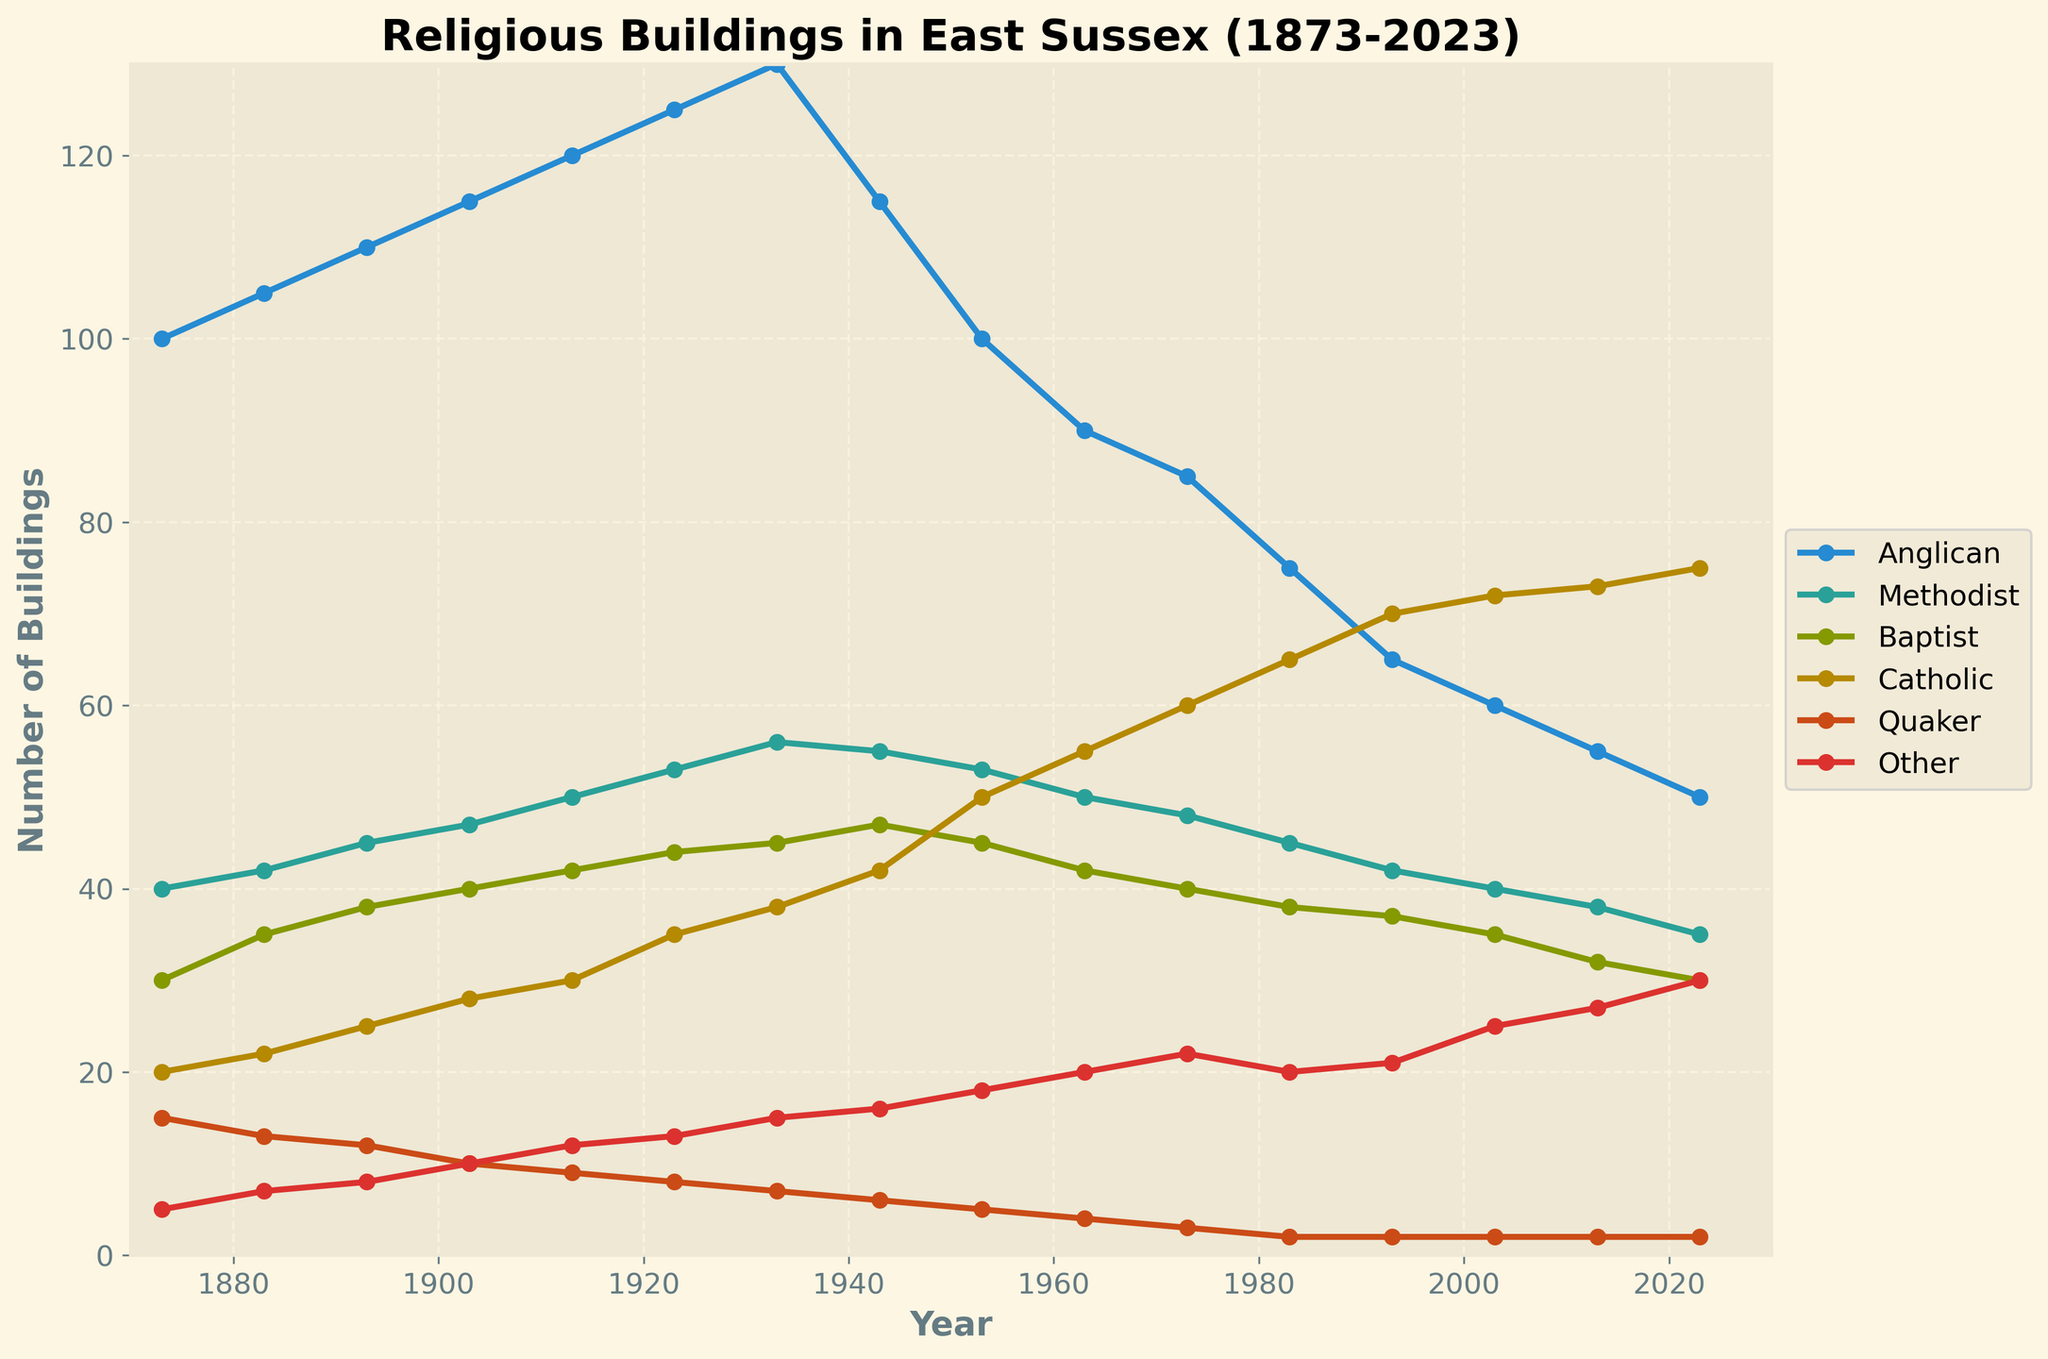What is the title of the plot? The title is displayed at the top of the plot, indicating the subject of the figure.
Answer: Religious Buildings in East Sussex (1873-2023) How many different religious denominations are represented in the figure? The legend on the right side of the figure indicates the number of different lines, each representing a different denomination.
Answer: 6 Which religious denomination had the highest number of buildings in 2023? Look at the endpoint for each line at the year 2023 to find which has the highest value.
Answer: Anglican How did the number of Anglican buildings change from 1873 to 2023? Compare the value at 1873 and the value at 2023 for the Anglican line to determine the change.
Answer: Decreased by 50 Which period saw the steepest decline in Methodist buildings? Observe the slope of the Methodist line over different time periods to determine where the steepest decline occurs.
Answer: 1933 to 1963 In which year did Catholic buildings surpass Baptist buildings for the first time? Look for the intersection point of the Catholic and Baptist lines on the plot and identify the corresponding year.
Answer: 1953 On average, how many buildings did the 'Other' category gain every decade from 1873 to 2023? Calculate the difference in the number of buildings in the 'Other' category from 1873 to 2023, then divide by the number of decades (15).
Answer: 1.67 buildings per decade During which decade did Quaker buildings experience the largest decrease? Identify the decade with the largest drop in the Quaker line by comparing values at the start and end of each decade.
Answer: 1933 to 1943 What general trend can be observed about the number of Catholic buildings from 1873 to 2023? Examine the overall direction and changes in the Catholic line over the years.
Answer: Increasing trend Which decade saw the greatest overall increase in total number of religious buildings? Sum the number of buildings for all denominations at the start and end of each decade to find the decade with the largest total increase.
Answer: 1923 to 1933 Is there a decade in which all religious denominations increased their number of buildings? Examine each line by decade to see if all lines show an upward trend within any given decade.
Answer: No 